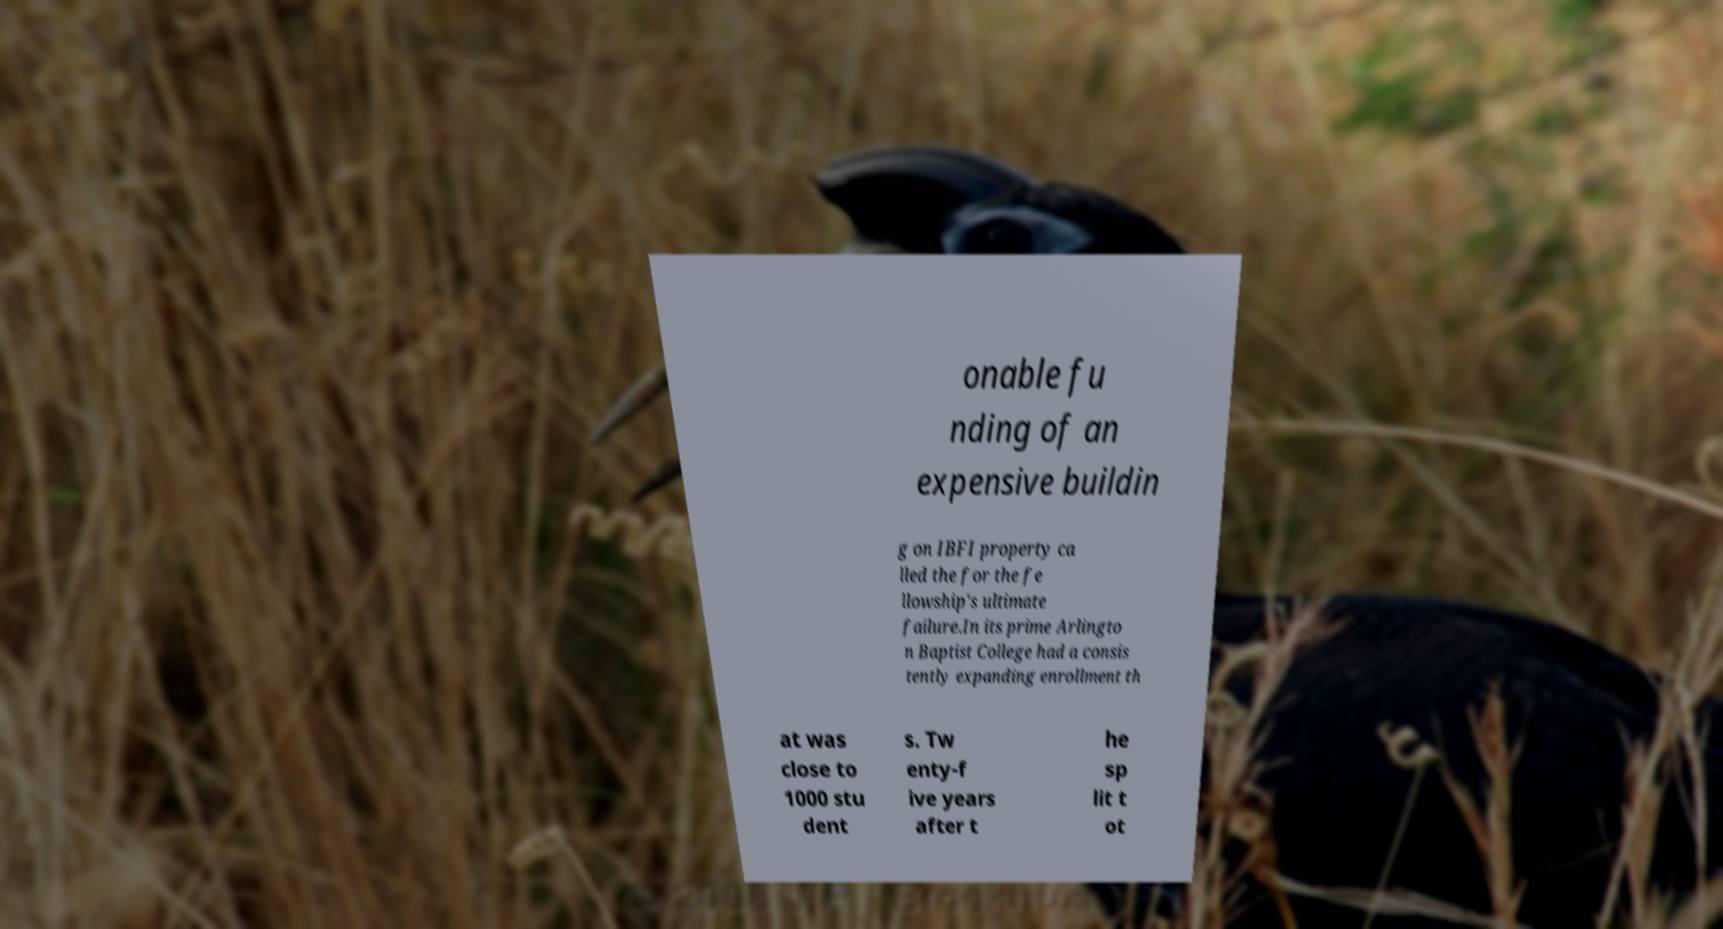I need the written content from this picture converted into text. Can you do that? onable fu nding of an expensive buildin g on IBFI property ca lled the for the fe llowship's ultimate failure.In its prime Arlingto n Baptist College had a consis tently expanding enrollment th at was close to 1000 stu dent s. Tw enty-f ive years after t he sp lit t ot 